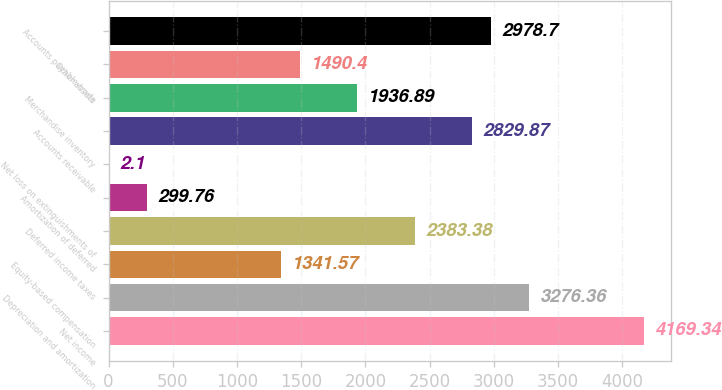Convert chart. <chart><loc_0><loc_0><loc_500><loc_500><bar_chart><fcel>Net income<fcel>Depreciation and amortization<fcel>Equity-based compensation<fcel>Deferred income taxes<fcel>Amortization of deferred<fcel>Net loss on extinguishments of<fcel>Accounts receivable<fcel>Merchandise inventory<fcel>Other assets<fcel>Accounts payable-trade<nl><fcel>4169.34<fcel>3276.36<fcel>1341.57<fcel>2383.38<fcel>299.76<fcel>2.1<fcel>2829.87<fcel>1936.89<fcel>1490.4<fcel>2978.7<nl></chart> 